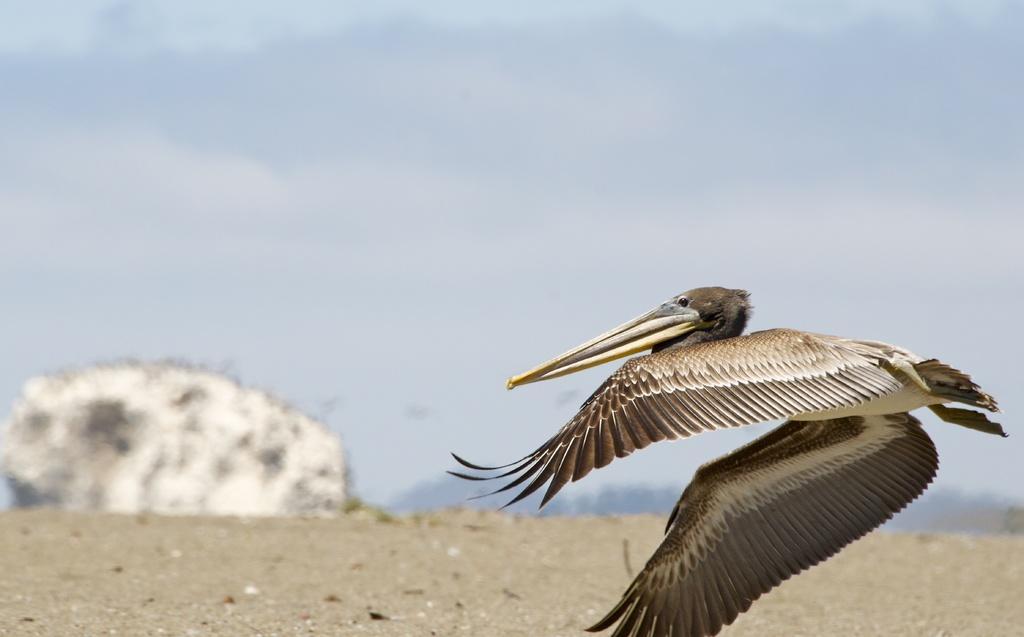Could you give a brief overview of what you see in this image? This image is taken outdoors. At the top of the image there is the sky with clouds. At the bottom of the image there is a ground. In this image the background is a little blurred. On the right side of the image there is a bird with a long beak. 